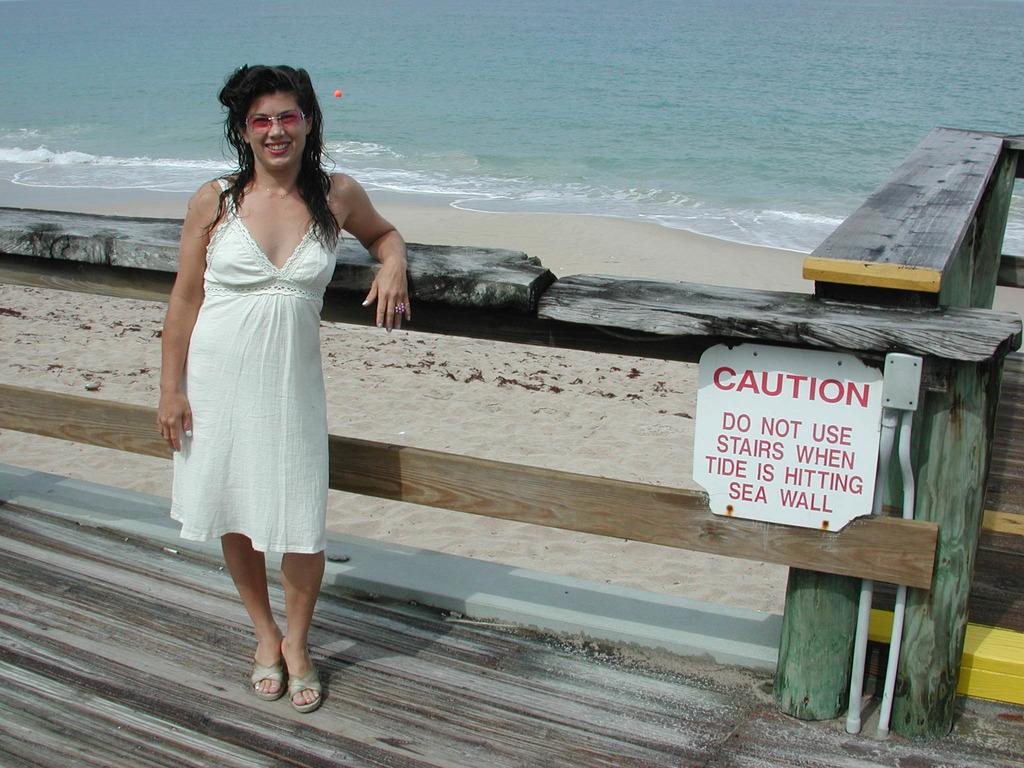What type of natural body of water is visible in the image? There is a sea in the image. What type of land is adjacent to the sea in the image? There is a beach in the image. What is the lady in the image standing on? The lady is standing on a wooden surface in the image. What type of barrier is present in the image? There is a fencing in the image. Can you see the snake flying with its wings in the image? There is no snake or wings present in the image. 